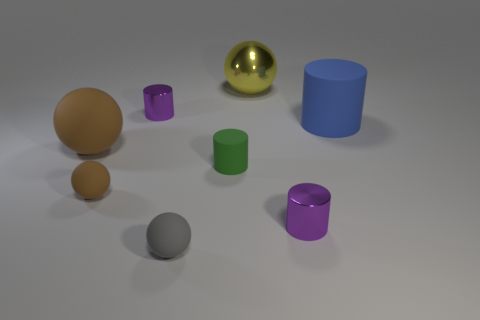Subtract all gray matte balls. How many balls are left? 3 Add 2 small green matte things. How many objects exist? 10 Subtract all brown spheres. How many spheres are left? 2 Subtract all small cylinders. Subtract all green matte things. How many objects are left? 4 Add 8 small gray matte spheres. How many small gray matte spheres are left? 9 Add 2 metallic blocks. How many metallic blocks exist? 2 Subtract 0 red cylinders. How many objects are left? 8 Subtract 4 cylinders. How many cylinders are left? 0 Subtract all yellow cylinders. Subtract all brown blocks. How many cylinders are left? 4 Subtract all yellow cylinders. How many brown balls are left? 2 